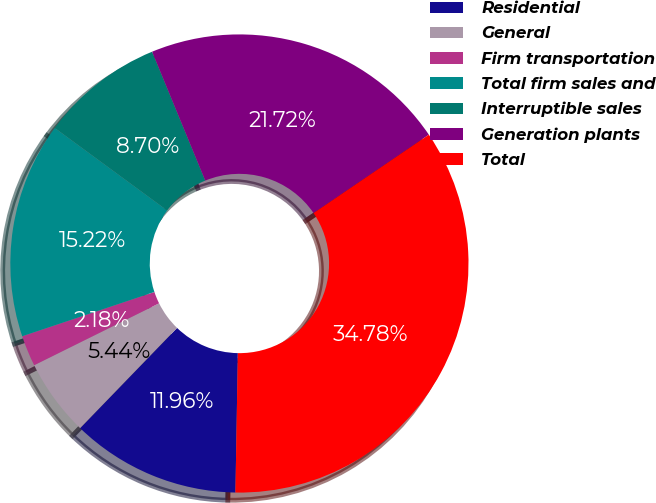Convert chart to OTSL. <chart><loc_0><loc_0><loc_500><loc_500><pie_chart><fcel>Residential<fcel>General<fcel>Firm transportation<fcel>Total firm sales and<fcel>Interruptible sales<fcel>Generation plants<fcel>Total<nl><fcel>11.96%<fcel>5.44%<fcel>2.18%<fcel>15.22%<fcel>8.7%<fcel>21.72%<fcel>34.78%<nl></chart> 